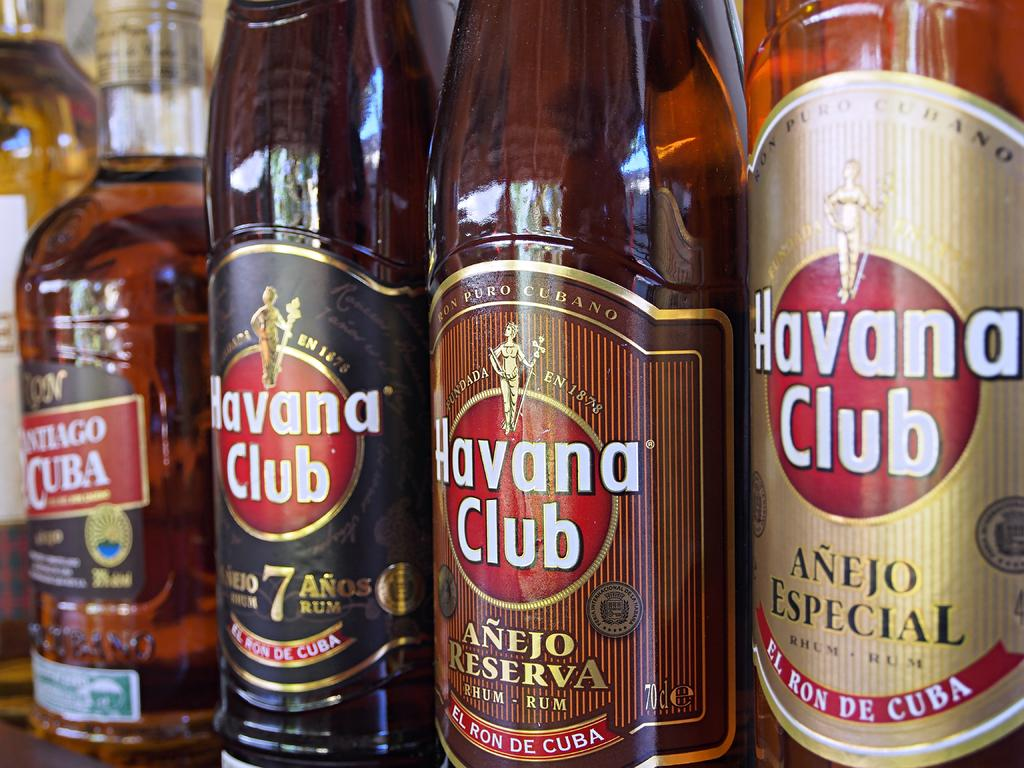What is contained in the bottles that are visible in the image? There are bottles with some drink in the image. How are the bottles arranged in the image? The bottles are arranged on shelves. What information is provided on the bottles in the image? There are labels attached to each bottle. What type of copper material can be seen in the image? There is no copper material present in the image. Is there a baby visible in the image? No, there is no baby present in the image. 